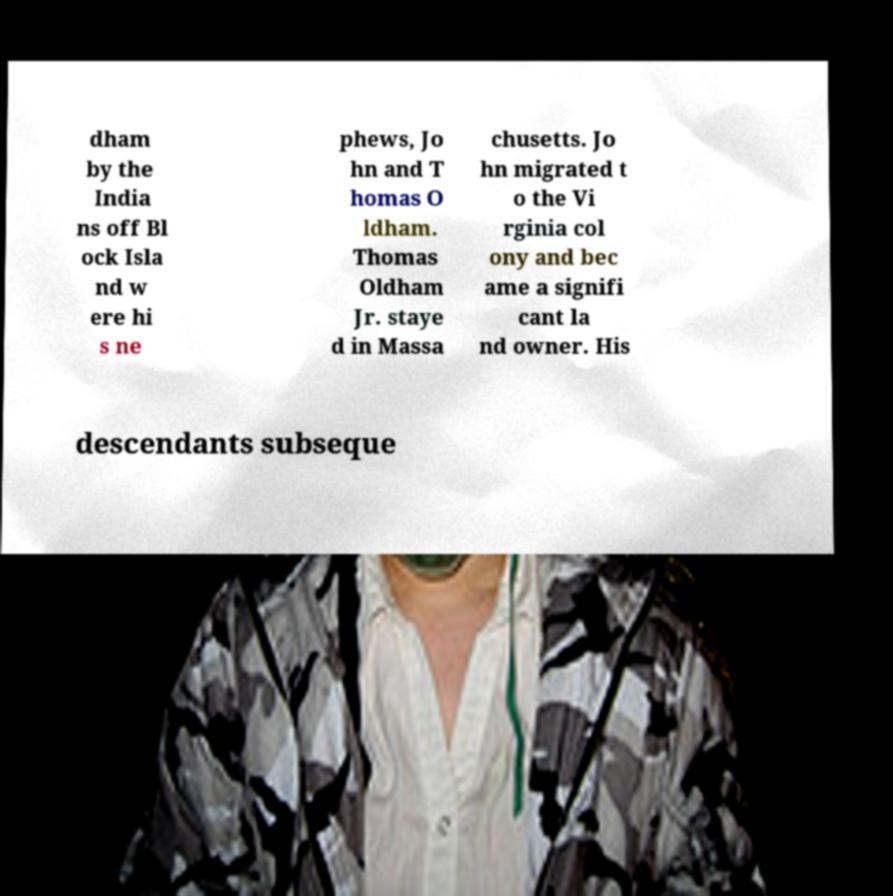Please read and relay the text visible in this image. What does it say? dham by the India ns off Bl ock Isla nd w ere hi s ne phews, Jo hn and T homas O ldham. Thomas Oldham Jr. staye d in Massa chusetts. Jo hn migrated t o the Vi rginia col ony and bec ame a signifi cant la nd owner. His descendants subseque 